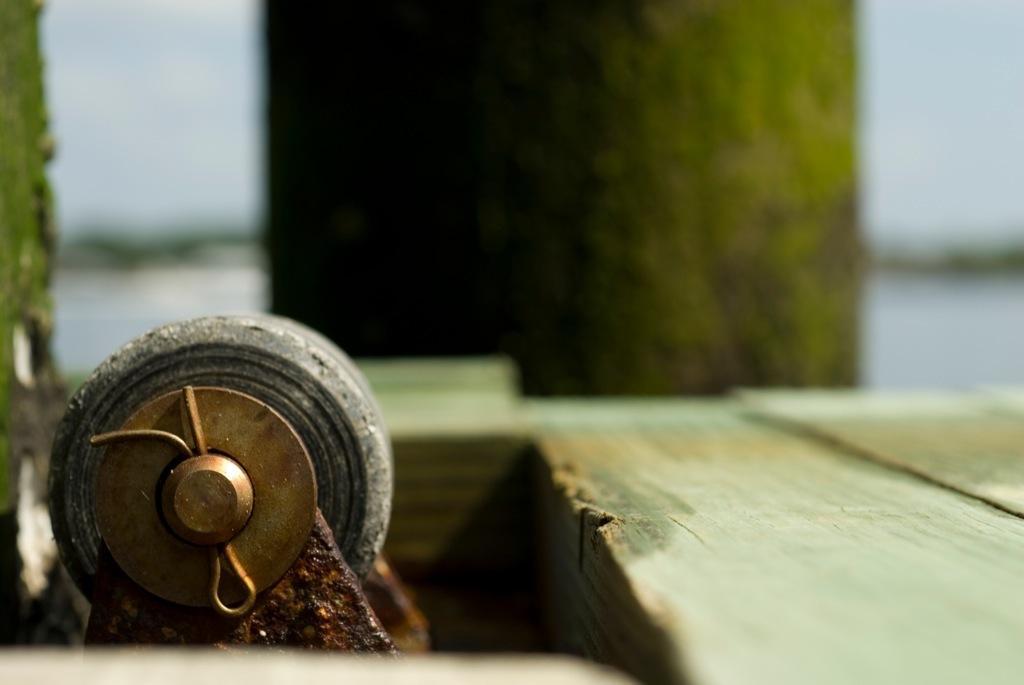Describe this image in one or two sentences. In this image we can see a wheel shaped object at the bottom. Also there is wooden base. In the background it is blur. 